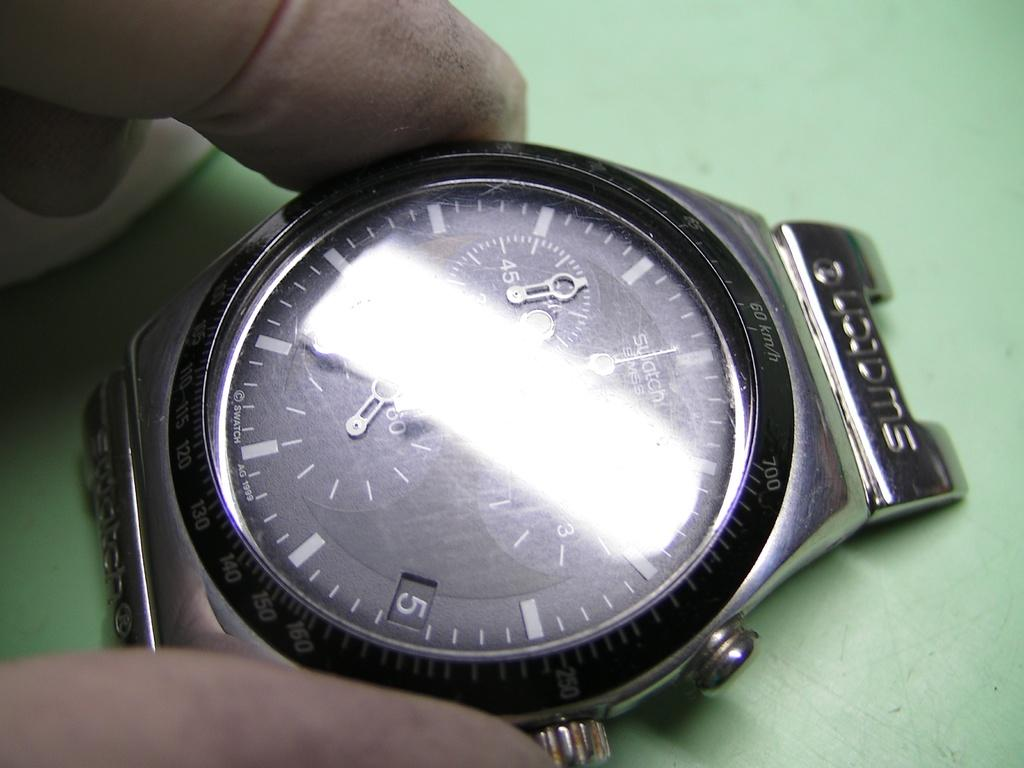<image>
Create a compact narrative representing the image presented. The brand of watch shown here is from Swatch 